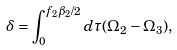Convert formula to latex. <formula><loc_0><loc_0><loc_500><loc_500>\delta = \int _ { 0 } ^ { f _ { 2 } \beta _ { 2 } / 2 } d \tau ( \Omega _ { 2 } - \Omega _ { 3 } ) ,</formula> 